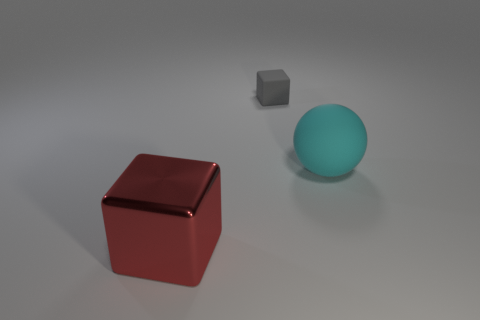Are there any other things that are the same size as the red object?
Ensure brevity in your answer.  Yes. Is the color of the rubber block the same as the block in front of the cyan rubber object?
Your answer should be very brief. No. What is the material of the big thing that is right of the thing on the left side of the small rubber block?
Give a very brief answer. Rubber. What number of things are in front of the gray rubber block and to the right of the large metallic thing?
Provide a short and direct response. 1. What number of other things are there of the same size as the cyan object?
Offer a terse response. 1. Does the object in front of the matte ball have the same shape as the big thing that is behind the big red object?
Your answer should be compact. No. There is a small gray object; are there any large red metallic objects behind it?
Keep it short and to the point. No. What color is the rubber thing that is the same shape as the big red metal object?
Give a very brief answer. Gray. Is there any other thing that is the same shape as the big cyan thing?
Your response must be concise. No. What is the material of the cube that is behind the red object?
Keep it short and to the point. Rubber. 